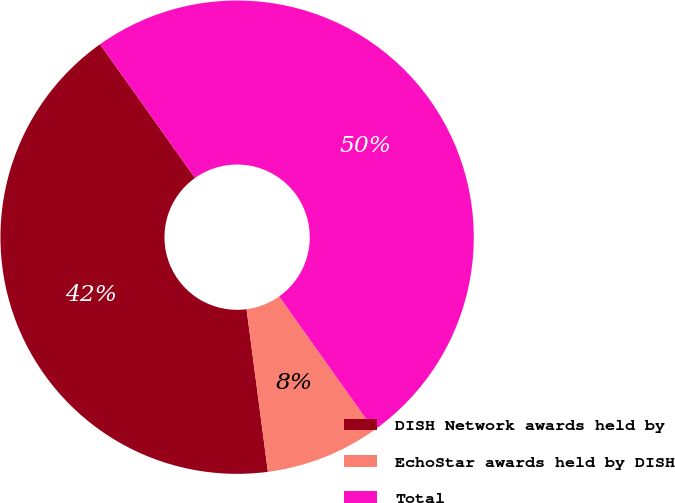Convert chart to OTSL. <chart><loc_0><loc_0><loc_500><loc_500><pie_chart><fcel>DISH Network awards held by<fcel>EchoStar awards held by DISH<fcel>Total<nl><fcel>42.25%<fcel>7.75%<fcel>50.0%<nl></chart> 